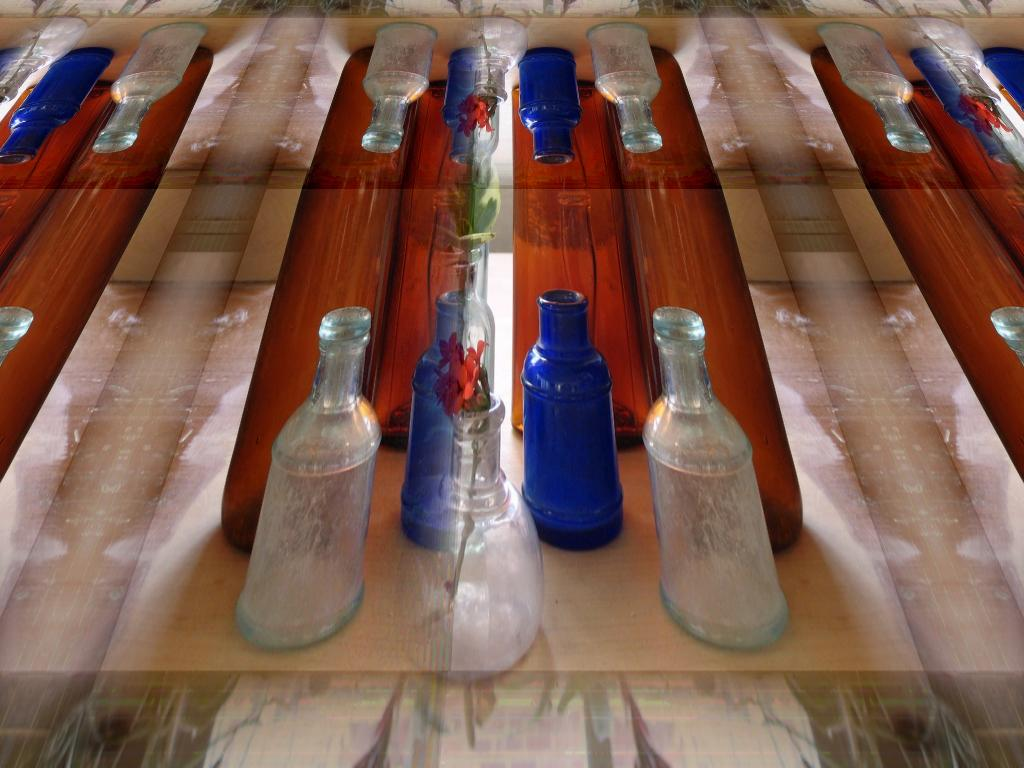What objects are present on the table in the image? There are bottles and a flower pot on the table in the image. Can you describe the flower pot in the image? The flower pot is a container for plants, and it is located on the table. What is the purpose of the bottles in the image? The purpose of the bottles is not explicitly stated, but they may contain liquid or other items. How does the flower pot increase in size as it runs towards the bottles? The flower pot does not increase in size or run towards the bottles in the image; it is a stationary object on the table. 